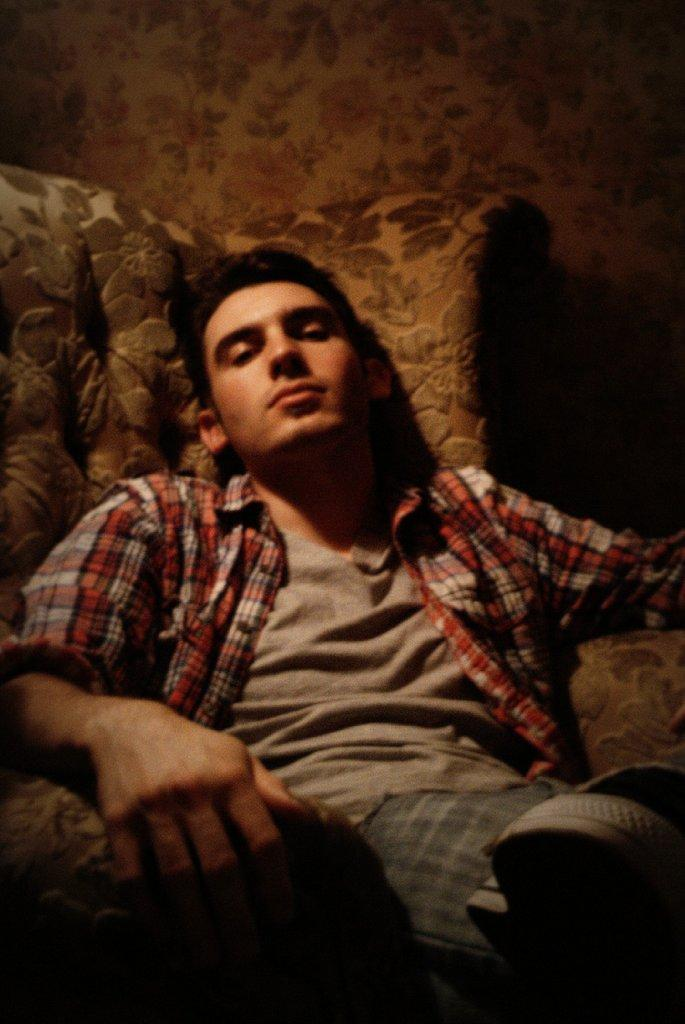What is the setting of the image? The image is of a room. Who is present in the room? There is a man in the room. What is the man wearing? The man is wearing a grey t-shirt. What is the man doing in the room? The man is sitting on a chair. What decorative item can be seen on the wall in the room? There is a floral painting on the wall in the room. What level of the building is the man standing on in the image? The image does not provide information about the level of the building, as it only shows a man sitting in a room. 